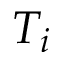Convert formula to latex. <formula><loc_0><loc_0><loc_500><loc_500>T _ { i }</formula> 